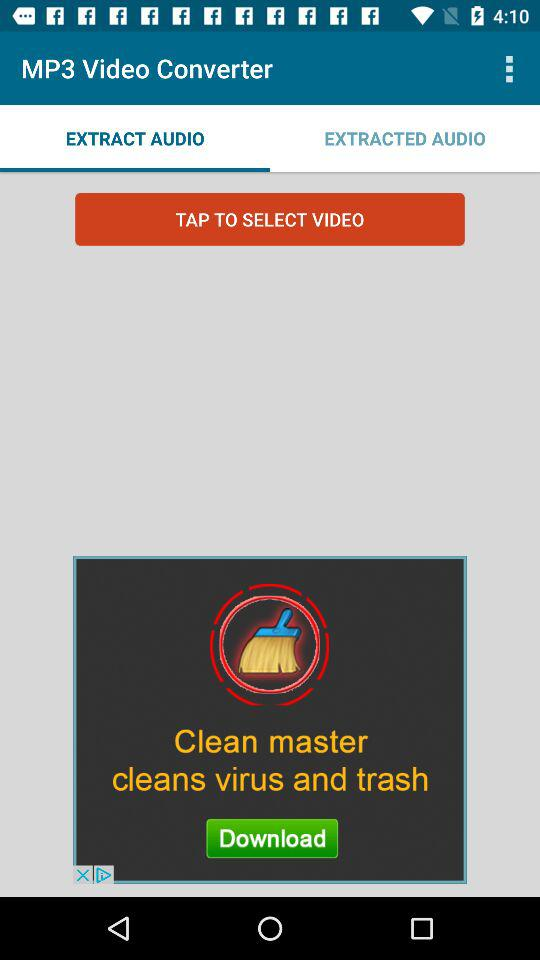Which option is selected in the "MP3 Video Converter"? The selected option is "EXTRACT AUDIO". 